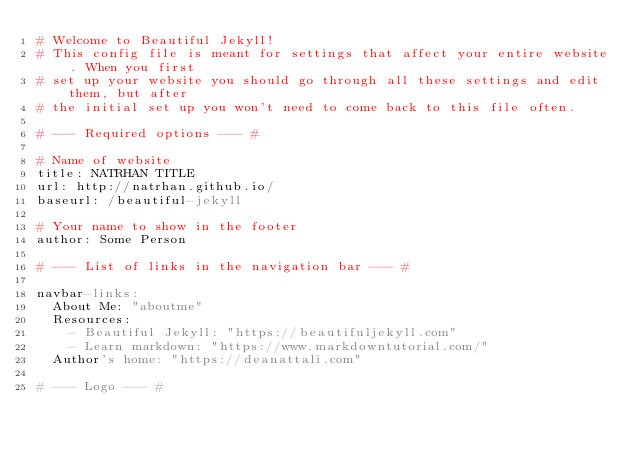Convert code to text. <code><loc_0><loc_0><loc_500><loc_500><_YAML_># Welcome to Beautiful Jekyll!
# This config file is meant for settings that affect your entire website. When you first
# set up your website you should go through all these settings and edit them, but after
# the initial set up you won't need to come back to this file often.

# --- Required options --- #

# Name of website
title: NATRHAN TITLE
url: http://natrhan.github.io/
baseurl: /beautiful-jekyll

# Your name to show in the footer
author: Some Person

# --- List of links in the navigation bar --- #

navbar-links:
  About Me: "aboutme"
  Resources:
    - Beautiful Jekyll: "https://beautifuljekyll.com"
    - Learn markdown: "https://www.markdowntutorial.com/"
  Author's home: "https://deanattali.com"

# --- Logo --- #
</code> 